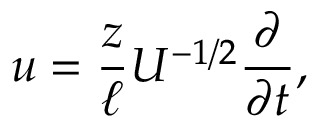<formula> <loc_0><loc_0><loc_500><loc_500>u = \frac { z } { \ell } U ^ { - 1 / 2 } \frac { \partial } { \partial t } ,</formula> 